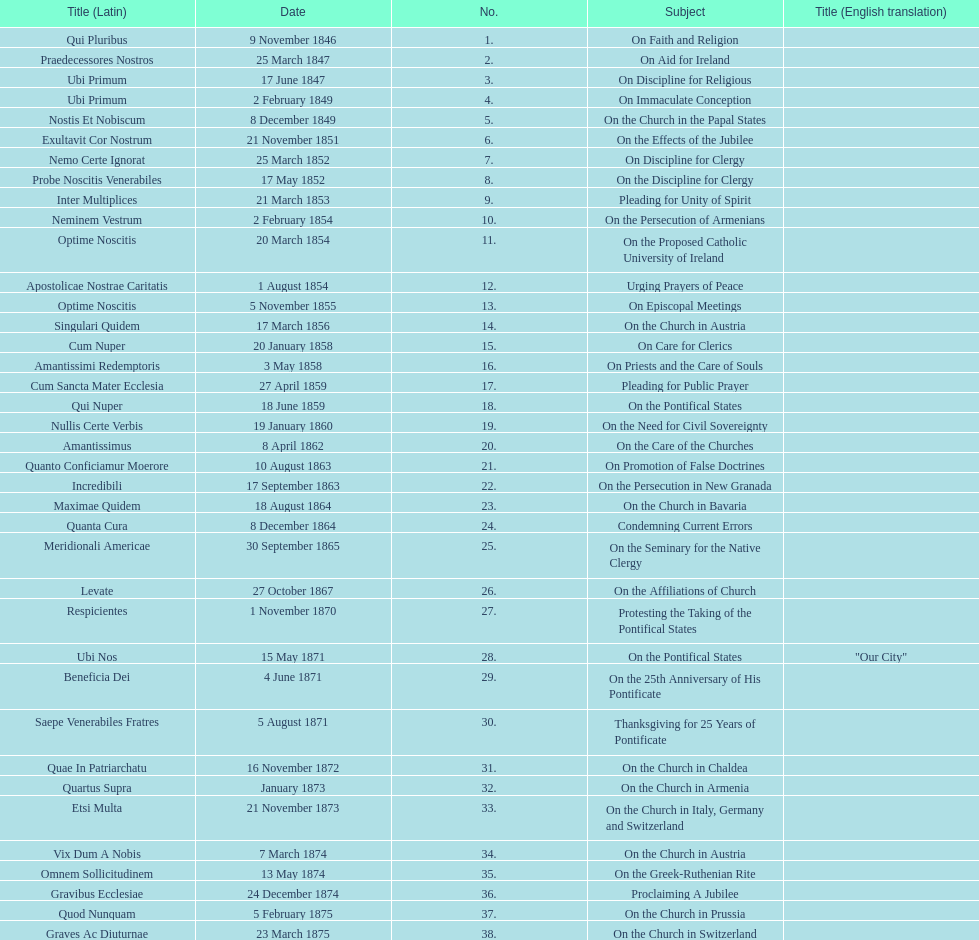Could you parse the entire table as a dict? {'header': ['Title (Latin)', 'Date', 'No.', 'Subject', 'Title (English translation)'], 'rows': [['Qui Pluribus', '9 November 1846', '1.', 'On Faith and Religion', ''], ['Praedecessores Nostros', '25 March 1847', '2.', 'On Aid for Ireland', ''], ['Ubi Primum', '17 June 1847', '3.', 'On Discipline for Religious', ''], ['Ubi Primum', '2 February 1849', '4.', 'On Immaculate Conception', ''], ['Nostis Et Nobiscum', '8 December 1849', '5.', 'On the Church in the Papal States', ''], ['Exultavit Cor Nostrum', '21 November 1851', '6.', 'On the Effects of the Jubilee', ''], ['Nemo Certe Ignorat', '25 March 1852', '7.', 'On Discipline for Clergy', ''], ['Probe Noscitis Venerabiles', '17 May 1852', '8.', 'On the Discipline for Clergy', ''], ['Inter Multiplices', '21 March 1853', '9.', 'Pleading for Unity of Spirit', ''], ['Neminem Vestrum', '2 February 1854', '10.', 'On the Persecution of Armenians', ''], ['Optime Noscitis', '20 March 1854', '11.', 'On the Proposed Catholic University of Ireland', ''], ['Apostolicae Nostrae Caritatis', '1 August 1854', '12.', 'Urging Prayers of Peace', ''], ['Optime Noscitis', '5 November 1855', '13.', 'On Episcopal Meetings', ''], ['Singulari Quidem', '17 March 1856', '14.', 'On the Church in Austria', ''], ['Cum Nuper', '20 January 1858', '15.', 'On Care for Clerics', ''], ['Amantissimi Redemptoris', '3 May 1858', '16.', 'On Priests and the Care of Souls', ''], ['Cum Sancta Mater Ecclesia', '27 April 1859', '17.', 'Pleading for Public Prayer', ''], ['Qui Nuper', '18 June 1859', '18.', 'On the Pontifical States', ''], ['Nullis Certe Verbis', '19 January 1860', '19.', 'On the Need for Civil Sovereignty', ''], ['Amantissimus', '8 April 1862', '20.', 'On the Care of the Churches', ''], ['Quanto Conficiamur Moerore', '10 August 1863', '21.', 'On Promotion of False Doctrines', ''], ['Incredibili', '17 September 1863', '22.', 'On the Persecution in New Granada', ''], ['Maximae Quidem', '18 August 1864', '23.', 'On the Church in Bavaria', ''], ['Quanta Cura', '8 December 1864', '24.', 'Condemning Current Errors', ''], ['Meridionali Americae', '30 September 1865', '25.', 'On the Seminary for the Native Clergy', ''], ['Levate', '27 October 1867', '26.', 'On the Affiliations of Church', ''], ['Respicientes', '1 November 1870', '27.', 'Protesting the Taking of the Pontifical States', ''], ['Ubi Nos', '15 May 1871', '28.', 'On the Pontifical States', '"Our City"'], ['Beneficia Dei', '4 June 1871', '29.', 'On the 25th Anniversary of His Pontificate', ''], ['Saepe Venerabiles Fratres', '5 August 1871', '30.', 'Thanksgiving for 25 Years of Pontificate', ''], ['Quae In Patriarchatu', '16 November 1872', '31.', 'On the Church in Chaldea', ''], ['Quartus Supra', 'January 1873', '32.', 'On the Church in Armenia', ''], ['Etsi Multa', '21 November 1873', '33.', 'On the Church in Italy, Germany and Switzerland', ''], ['Vix Dum A Nobis', '7 March 1874', '34.', 'On the Church in Austria', ''], ['Omnem Sollicitudinem', '13 May 1874', '35.', 'On the Greek-Ruthenian Rite', ''], ['Gravibus Ecclesiae', '24 December 1874', '36.', 'Proclaiming A Jubilee', ''], ['Quod Nunquam', '5 February 1875', '37.', 'On the Church in Prussia', ''], ['Graves Ac Diuturnae', '23 March 1875', '38.', 'On the Church in Switzerland', '']]} What is the last title? Graves Ac Diuturnae. 